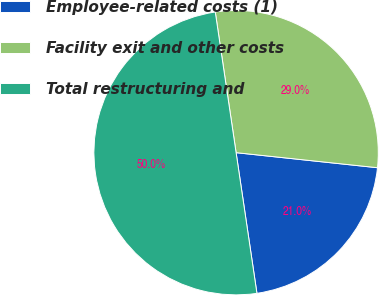<chart> <loc_0><loc_0><loc_500><loc_500><pie_chart><fcel>Employee-related costs (1)<fcel>Facility exit and other costs<fcel>Total restructuring and<nl><fcel>20.97%<fcel>29.03%<fcel>50.0%<nl></chart> 